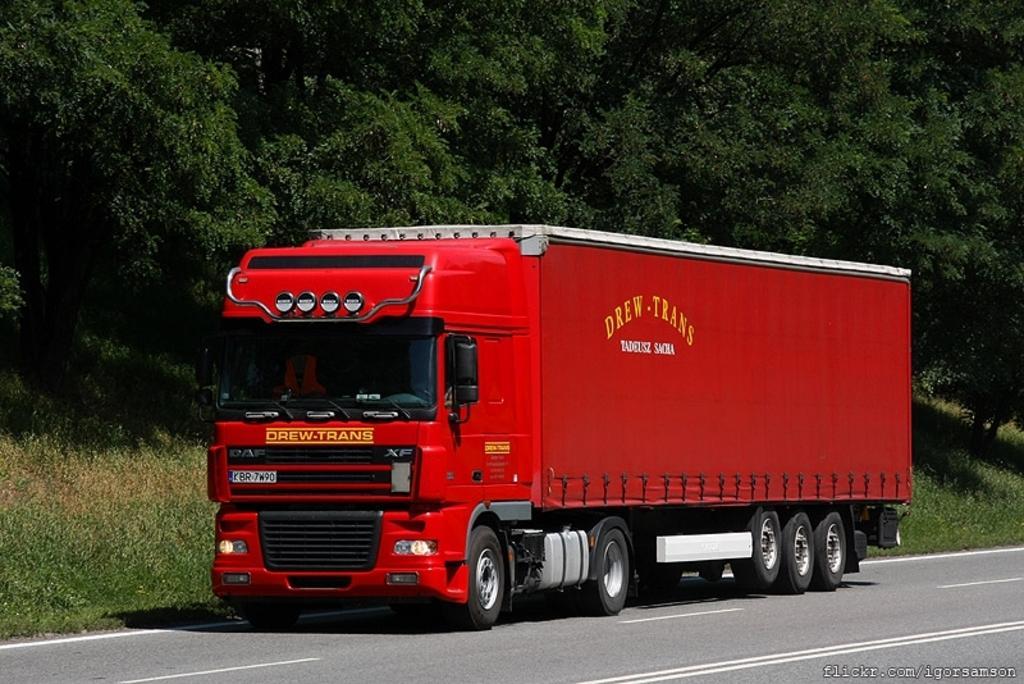How would you summarize this image in a sentence or two? In this image in the center there is one vehicle on the road in the background there are some trees and grass. 